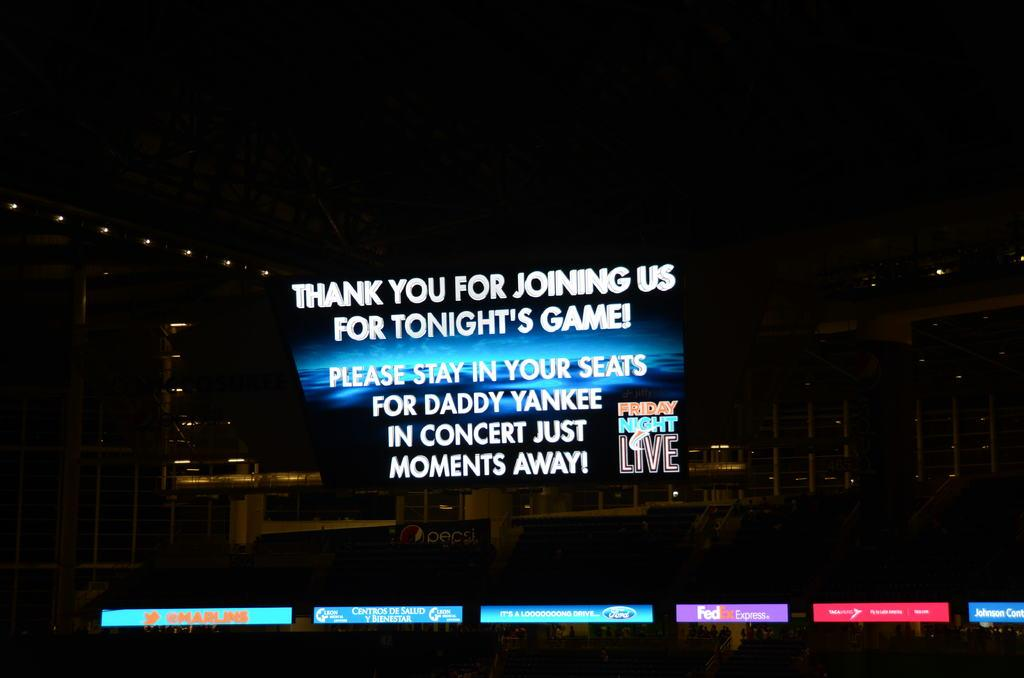<image>
Write a terse but informative summary of the picture. A large scoreboard displays a message regarding the Daddy Yankee concert. 